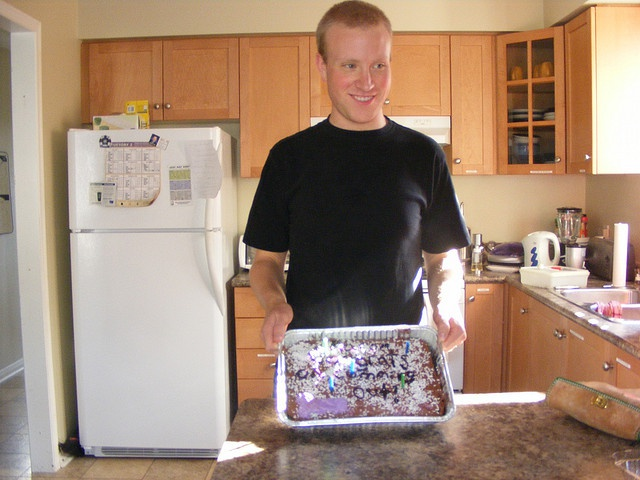Describe the objects in this image and their specific colors. I can see refrigerator in tan, lightgray, and darkgray tones, people in tan, black, salmon, and gray tones, dining table in tan, gray, brown, and white tones, cake in tan, darkgray, lightgray, and gray tones, and handbag in tan, gray, and brown tones in this image. 